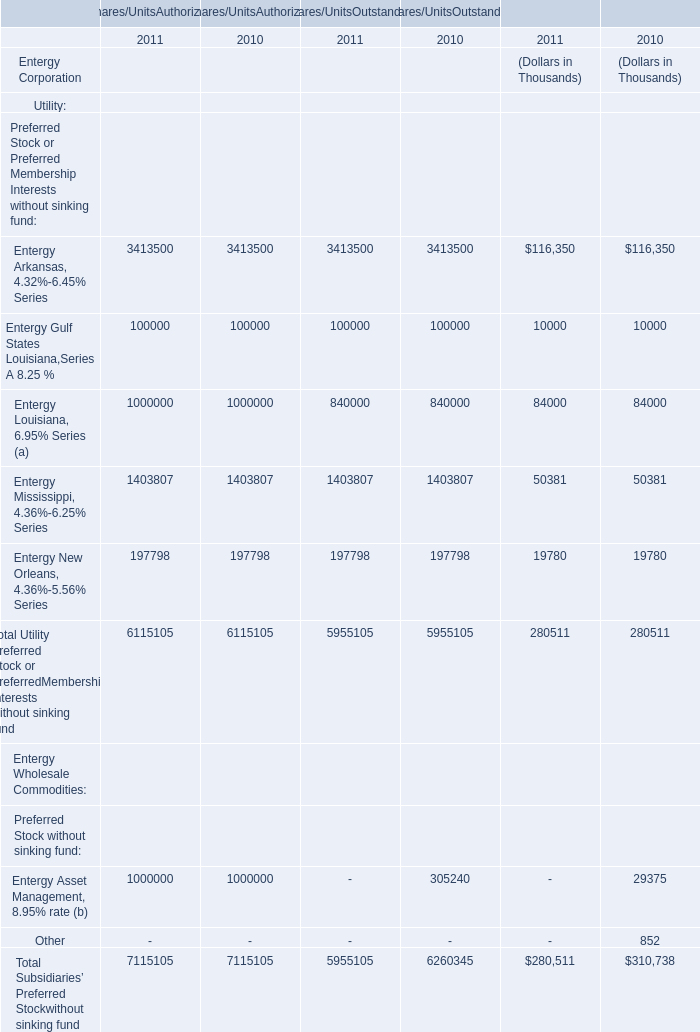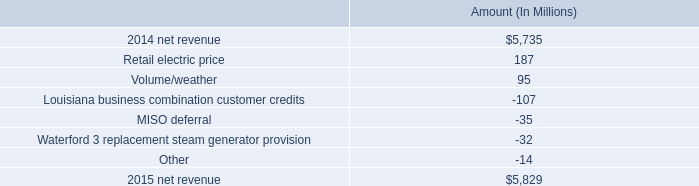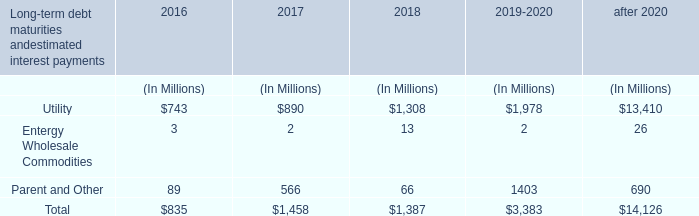What will Entergy Gulf States Louisiana,Series A 8.25 % reach in 2011 if it continues to grow at its current rate? (in Thousand) 
Computations: ((((((100000 + 100000) + 100000) - ((100000 + 100000) + 100000)) / ((100000 + 100000) + 100000)) * ((100000 + 100000) + 100000)) + ((100000 + 100000) + 100000))
Answer: 300000.0. 